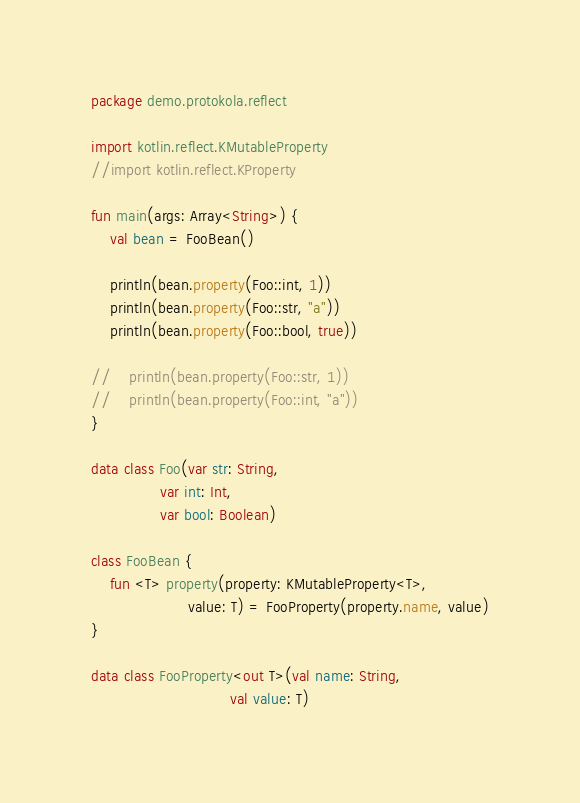<code> <loc_0><loc_0><loc_500><loc_500><_Kotlin_>package demo.protokola.reflect

import kotlin.reflect.KMutableProperty
//import kotlin.reflect.KProperty

fun main(args: Array<String>) {
    val bean = FooBean()

    println(bean.property(Foo::int, 1))
    println(bean.property(Foo::str, "a"))
    println(bean.property(Foo::bool, true))

//    println(bean.property(Foo::str, 1))
//    println(bean.property(Foo::int, "a"))
}

data class Foo(var str: String,
               var int: Int,
               var bool: Boolean)

class FooBean {
    fun <T> property(property: KMutableProperty<T>,
                     value: T) = FooProperty(property.name, value)
}

data class FooProperty<out T>(val name: String,
                              val value: T)
</code> 